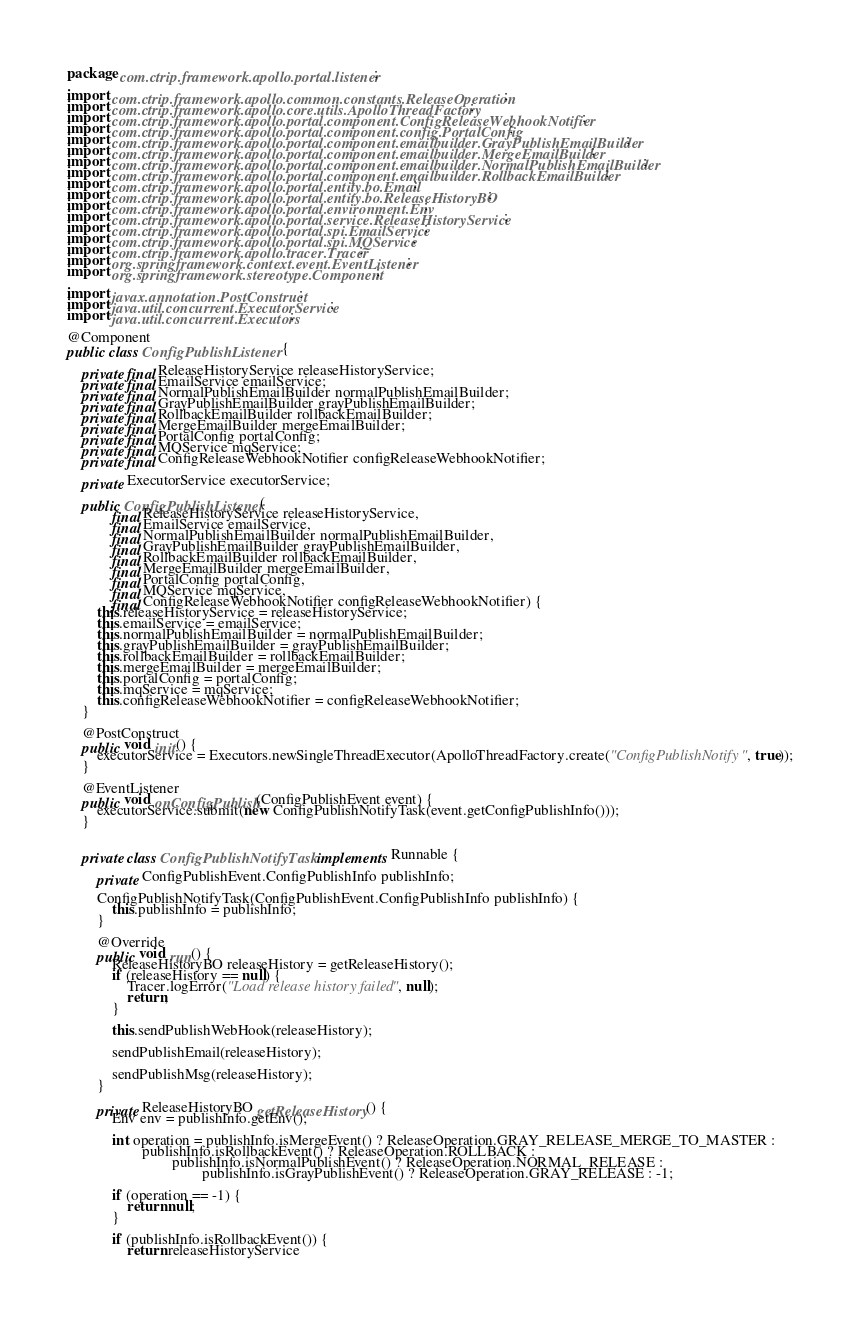<code> <loc_0><loc_0><loc_500><loc_500><_Java_>package com.ctrip.framework.apollo.portal.listener;

import com.ctrip.framework.apollo.common.constants.ReleaseOperation;
import com.ctrip.framework.apollo.core.utils.ApolloThreadFactory;
import com.ctrip.framework.apollo.portal.component.ConfigReleaseWebhookNotifier;
import com.ctrip.framework.apollo.portal.component.config.PortalConfig;
import com.ctrip.framework.apollo.portal.component.emailbuilder.GrayPublishEmailBuilder;
import com.ctrip.framework.apollo.portal.component.emailbuilder.MergeEmailBuilder;
import com.ctrip.framework.apollo.portal.component.emailbuilder.NormalPublishEmailBuilder;
import com.ctrip.framework.apollo.portal.component.emailbuilder.RollbackEmailBuilder;
import com.ctrip.framework.apollo.portal.entity.bo.Email;
import com.ctrip.framework.apollo.portal.entity.bo.ReleaseHistoryBO;
import com.ctrip.framework.apollo.portal.environment.Env;
import com.ctrip.framework.apollo.portal.service.ReleaseHistoryService;
import com.ctrip.framework.apollo.portal.spi.EmailService;
import com.ctrip.framework.apollo.portal.spi.MQService;
import com.ctrip.framework.apollo.tracer.Tracer;
import org.springframework.context.event.EventListener;
import org.springframework.stereotype.Component;

import javax.annotation.PostConstruct;
import java.util.concurrent.ExecutorService;
import java.util.concurrent.Executors;

@Component
public class ConfigPublishListener {

    private final ReleaseHistoryService releaseHistoryService;
    private final EmailService emailService;
    private final NormalPublishEmailBuilder normalPublishEmailBuilder;
    private final GrayPublishEmailBuilder grayPublishEmailBuilder;
    private final RollbackEmailBuilder rollbackEmailBuilder;
    private final MergeEmailBuilder mergeEmailBuilder;
    private final PortalConfig portalConfig;
    private final MQService mqService;
    private final ConfigReleaseWebhookNotifier configReleaseWebhookNotifier;

    private ExecutorService executorService;

    public ConfigPublishListener(
            final ReleaseHistoryService releaseHistoryService,
            final EmailService emailService,
            final NormalPublishEmailBuilder normalPublishEmailBuilder,
            final GrayPublishEmailBuilder grayPublishEmailBuilder,
            final RollbackEmailBuilder rollbackEmailBuilder,
            final MergeEmailBuilder mergeEmailBuilder,
            final PortalConfig portalConfig,
            final MQService mqService,
            final ConfigReleaseWebhookNotifier configReleaseWebhookNotifier) {
        this.releaseHistoryService = releaseHistoryService;
        this.emailService = emailService;
        this.normalPublishEmailBuilder = normalPublishEmailBuilder;
        this.grayPublishEmailBuilder = grayPublishEmailBuilder;
        this.rollbackEmailBuilder = rollbackEmailBuilder;
        this.mergeEmailBuilder = mergeEmailBuilder;
        this.portalConfig = portalConfig;
        this.mqService = mqService;
        this.configReleaseWebhookNotifier = configReleaseWebhookNotifier;
    }

    @PostConstruct
    public void init() {
        executorService = Executors.newSingleThreadExecutor(ApolloThreadFactory.create("ConfigPublishNotify", true));
    }

    @EventListener
    public void onConfigPublish(ConfigPublishEvent event) {
        executorService.submit(new ConfigPublishNotifyTask(event.getConfigPublishInfo()));
    }


    private class ConfigPublishNotifyTask implements Runnable {

        private ConfigPublishEvent.ConfigPublishInfo publishInfo;

        ConfigPublishNotifyTask(ConfigPublishEvent.ConfigPublishInfo publishInfo) {
            this.publishInfo = publishInfo;
        }

        @Override
        public void run() {
            ReleaseHistoryBO releaseHistory = getReleaseHistory();
            if (releaseHistory == null) {
                Tracer.logError("Load release history failed", null);
                return;
            }

            this.sendPublishWebHook(releaseHistory);

            sendPublishEmail(releaseHistory);

            sendPublishMsg(releaseHistory);
        }

        private ReleaseHistoryBO getReleaseHistory() {
            Env env = publishInfo.getEnv();

            int operation = publishInfo.isMergeEvent() ? ReleaseOperation.GRAY_RELEASE_MERGE_TO_MASTER :
                    publishInfo.isRollbackEvent() ? ReleaseOperation.ROLLBACK :
                            publishInfo.isNormalPublishEvent() ? ReleaseOperation.NORMAL_RELEASE :
                                    publishInfo.isGrayPublishEvent() ? ReleaseOperation.GRAY_RELEASE : -1;

            if (operation == -1) {
                return null;
            }

            if (publishInfo.isRollbackEvent()) {
                return releaseHistoryService</code> 